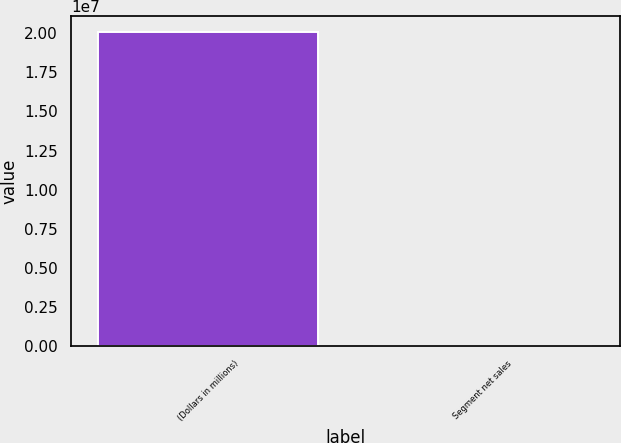Convert chart to OTSL. <chart><loc_0><loc_0><loc_500><loc_500><bar_chart><fcel>(Dollars in millions)<fcel>Segment net sales<nl><fcel>2.0082e+07<fcel>36<nl></chart> 